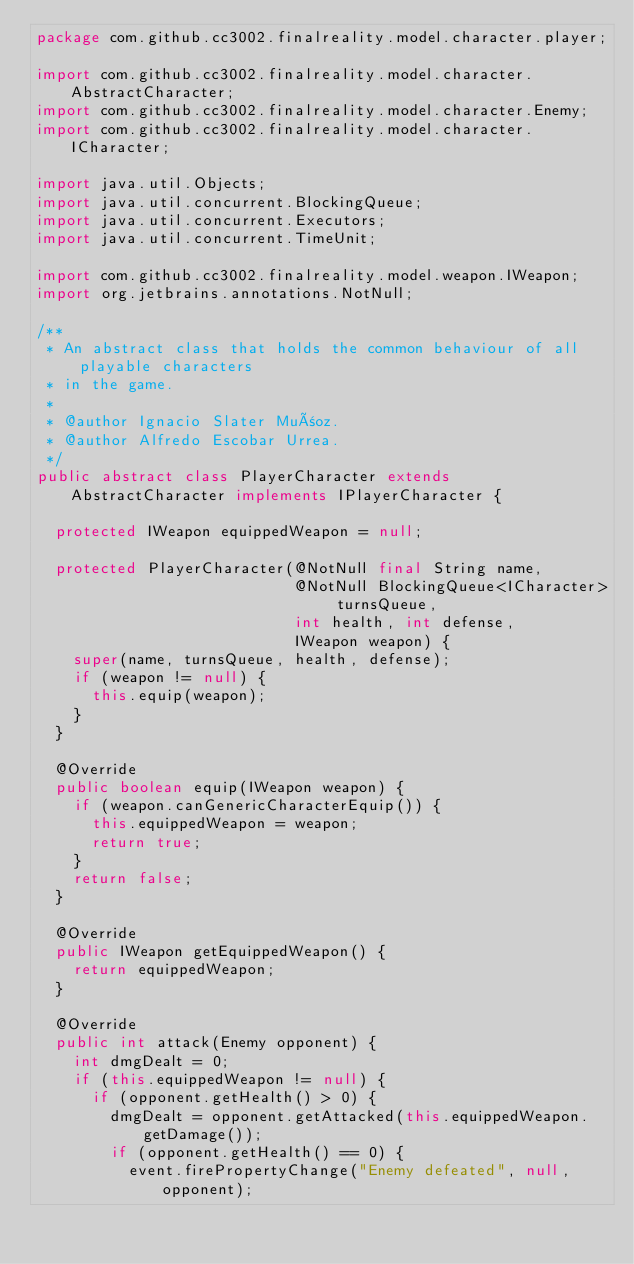<code> <loc_0><loc_0><loc_500><loc_500><_Java_>package com.github.cc3002.finalreality.model.character.player;

import com.github.cc3002.finalreality.model.character.AbstractCharacter;
import com.github.cc3002.finalreality.model.character.Enemy;
import com.github.cc3002.finalreality.model.character.ICharacter;

import java.util.Objects;
import java.util.concurrent.BlockingQueue;
import java.util.concurrent.Executors;
import java.util.concurrent.TimeUnit;

import com.github.cc3002.finalreality.model.weapon.IWeapon;
import org.jetbrains.annotations.NotNull;

/**
 * An abstract class that holds the common behaviour of all playable characters
 * in the game.
 *
 * @author Ignacio Slater Muñoz.
 * @author Alfredo Escobar Urrea.
 */
public abstract class PlayerCharacter extends AbstractCharacter implements IPlayerCharacter {

  protected IWeapon equippedWeapon = null;

  protected PlayerCharacter(@NotNull final String name,
                            @NotNull BlockingQueue<ICharacter> turnsQueue,
                            int health, int defense,
                            IWeapon weapon) {
    super(name, turnsQueue, health, defense);
    if (weapon != null) {
      this.equip(weapon);
    }
  }

  @Override
  public boolean equip(IWeapon weapon) {
    if (weapon.canGenericCharacterEquip()) {
      this.equippedWeapon = weapon;
      return true;
    }
    return false;
  }

  @Override
  public IWeapon getEquippedWeapon() {
    return equippedWeapon;
  }

  @Override
  public int attack(Enemy opponent) {
    int dmgDealt = 0;
    if (this.equippedWeapon != null) {
      if (opponent.getHealth() > 0) {
        dmgDealt = opponent.getAttacked(this.equippedWeapon.getDamage());
        if (opponent.getHealth() == 0) {
          event.firePropertyChange("Enemy defeated", null, opponent);</code> 